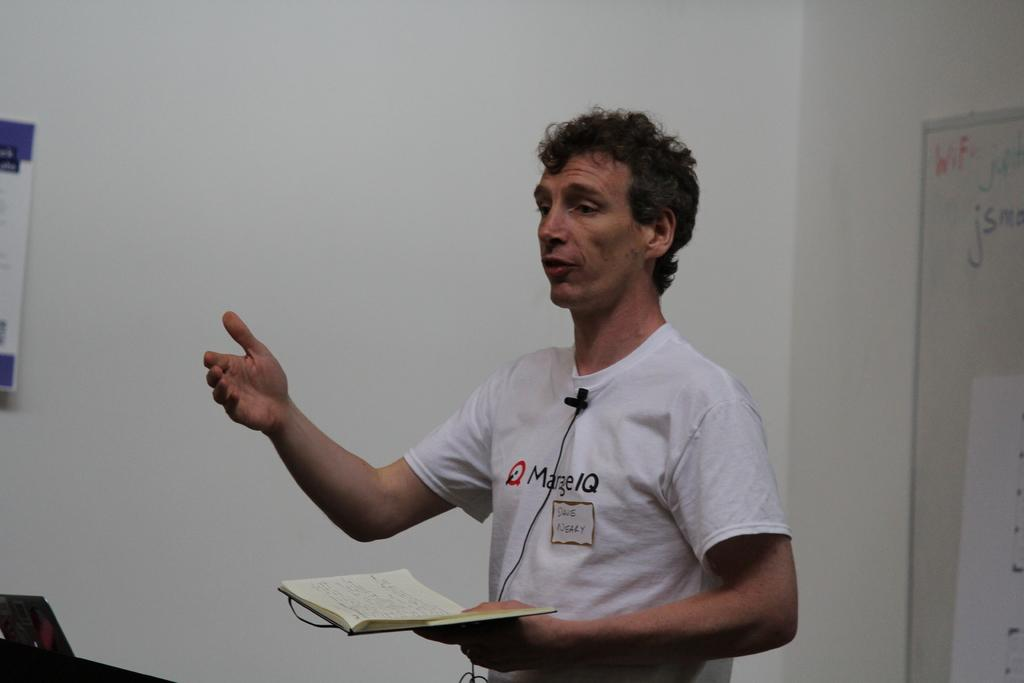Who is present in the image? There is a man in the image. What is the man holding in the image? The man is holding a book. What is the man doing in the image? The man is talking. What color is the wall in the image? The wall in the image is white. What can be seen on the wall in the image? There is a poster and a board on the wall. Can you see any roots growing on the wall in the image? There are no roots visible in the image; the wall is white, and there is a poster and a board on it. 